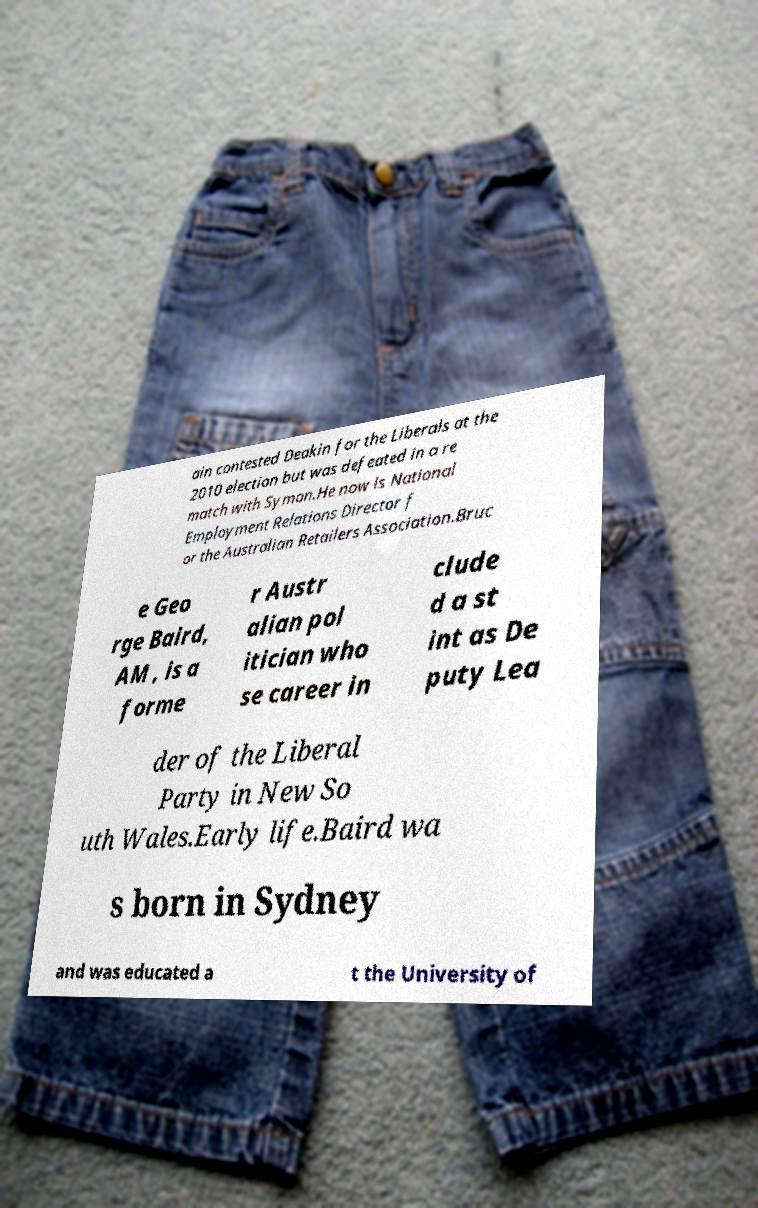I need the written content from this picture converted into text. Can you do that? ain contested Deakin for the Liberals at the 2010 election but was defeated in a re match with Symon.He now is National Employment Relations Director f or the Australian Retailers Association.Bruc e Geo rge Baird, AM , is a forme r Austr alian pol itician who se career in clude d a st int as De puty Lea der of the Liberal Party in New So uth Wales.Early life.Baird wa s born in Sydney and was educated a t the University of 